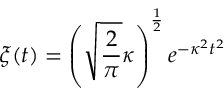Convert formula to latex. <formula><loc_0><loc_0><loc_500><loc_500>\xi ( t ) = \left ( \sqrt { \frac { 2 } { \pi } } \kappa \right ) ^ { \frac { 1 } { 2 } } e ^ { - \kappa ^ { 2 } t ^ { 2 } }</formula> 